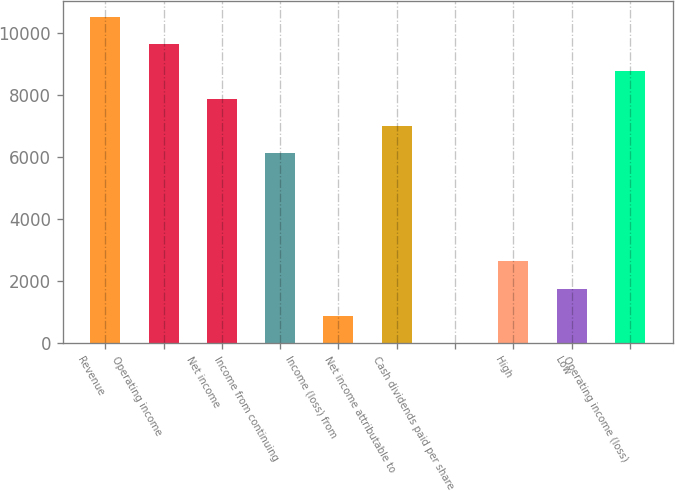<chart> <loc_0><loc_0><loc_500><loc_500><bar_chart><fcel>Revenue<fcel>Operating income<fcel>Net income<fcel>Income from continuing<fcel>Income (loss) from<fcel>Net income attributable to<fcel>Cash dividends paid per share<fcel>High<fcel>Low<fcel>Operating income (loss)<nl><fcel>10523.9<fcel>9646.96<fcel>7893<fcel>6139.04<fcel>877.16<fcel>7016.02<fcel>0.18<fcel>2631.12<fcel>1754.14<fcel>8769.98<nl></chart> 